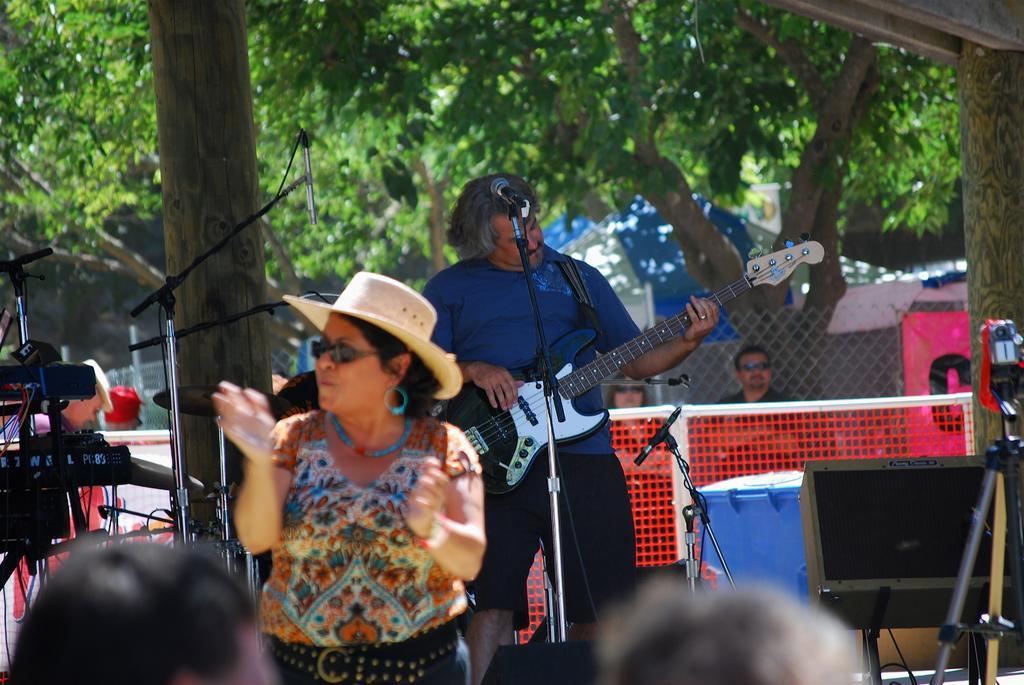Can you describe this image briefly? In this picture I can see a man standing and playing a guitar, there is a woman standing, there are heads of two persons, there are few people, there are cymbals with the cymbals stands, there are mike's stands, it is looking like a sports net, there is a tent, there is fence and there are some other objects, and in the background there are trees. 